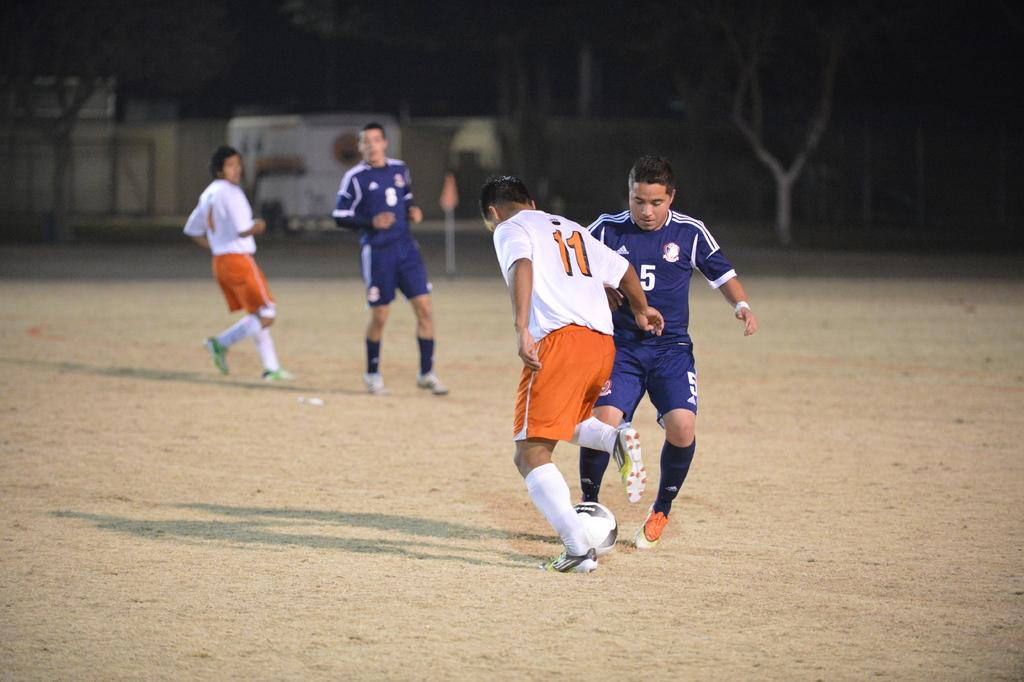How many people are present in the image? There are four people in the image. What are the people doing in the image? The people are playing with a ball. Where is the ball located in the image? The ball is on the ground. What can be seen in the background of the image? There are trees in the background of the image. What type of jewel is the ball made of in the image? The ball is not made of a jewel; it is a regular ball used for playing. Can you tell me which toy the people are playing with in the image? The people are playing with a ball, which is not a toy in this context. 